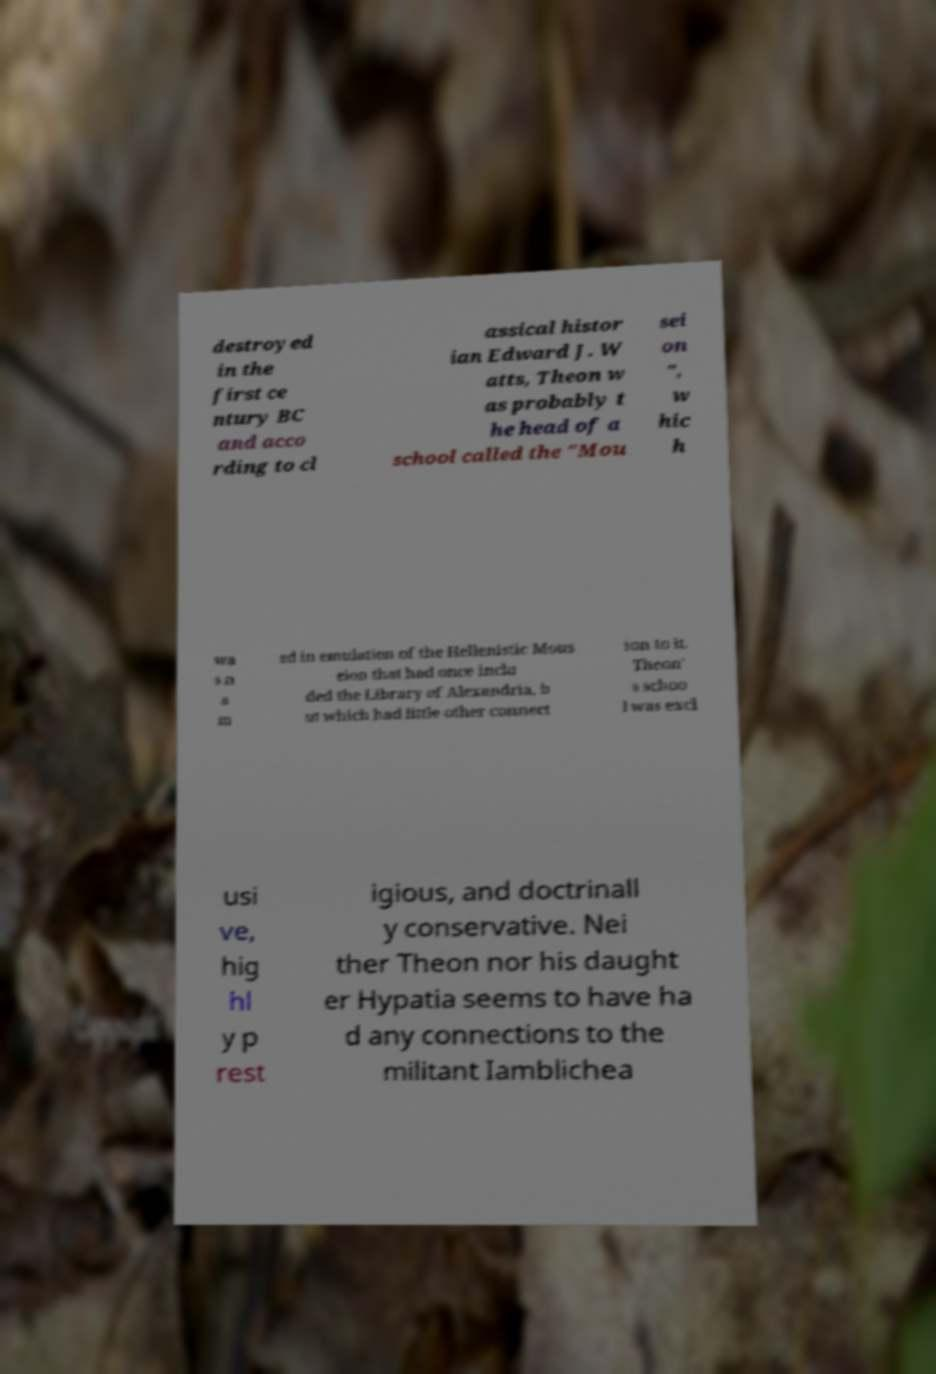Please identify and transcribe the text found in this image. destroyed in the first ce ntury BC and acco rding to cl assical histor ian Edward J. W atts, Theon w as probably t he head of a school called the "Mou sei on ", w hic h wa s n a m ed in emulation of the Hellenistic Mous eion that had once inclu ded the Library of Alexandria, b ut which had little other connect ion to it. Theon' s schoo l was excl usi ve, hig hl y p rest igious, and doctrinall y conservative. Nei ther Theon nor his daught er Hypatia seems to have ha d any connections to the militant Iamblichea 